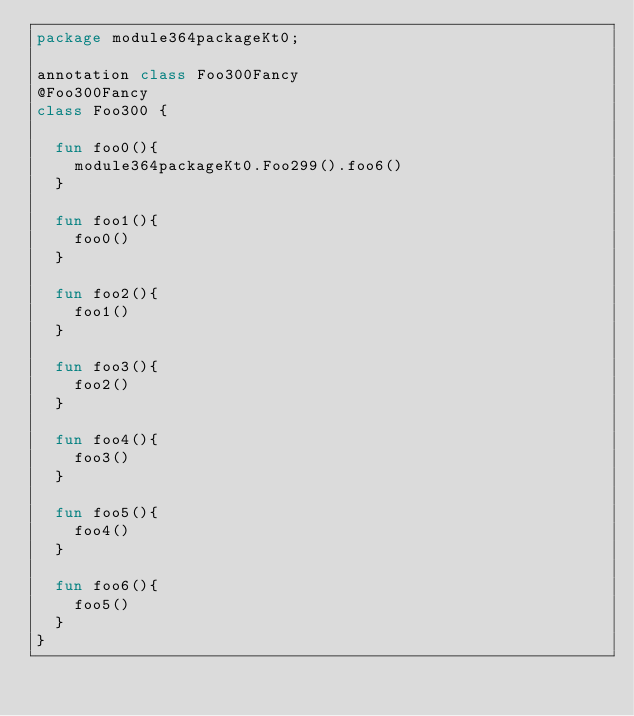<code> <loc_0><loc_0><loc_500><loc_500><_Kotlin_>package module364packageKt0;

annotation class Foo300Fancy
@Foo300Fancy
class Foo300 {

  fun foo0(){
    module364packageKt0.Foo299().foo6()
  }

  fun foo1(){
    foo0()
  }

  fun foo2(){
    foo1()
  }

  fun foo3(){
    foo2()
  }

  fun foo4(){
    foo3()
  }

  fun foo5(){
    foo4()
  }

  fun foo6(){
    foo5()
  }
}</code> 